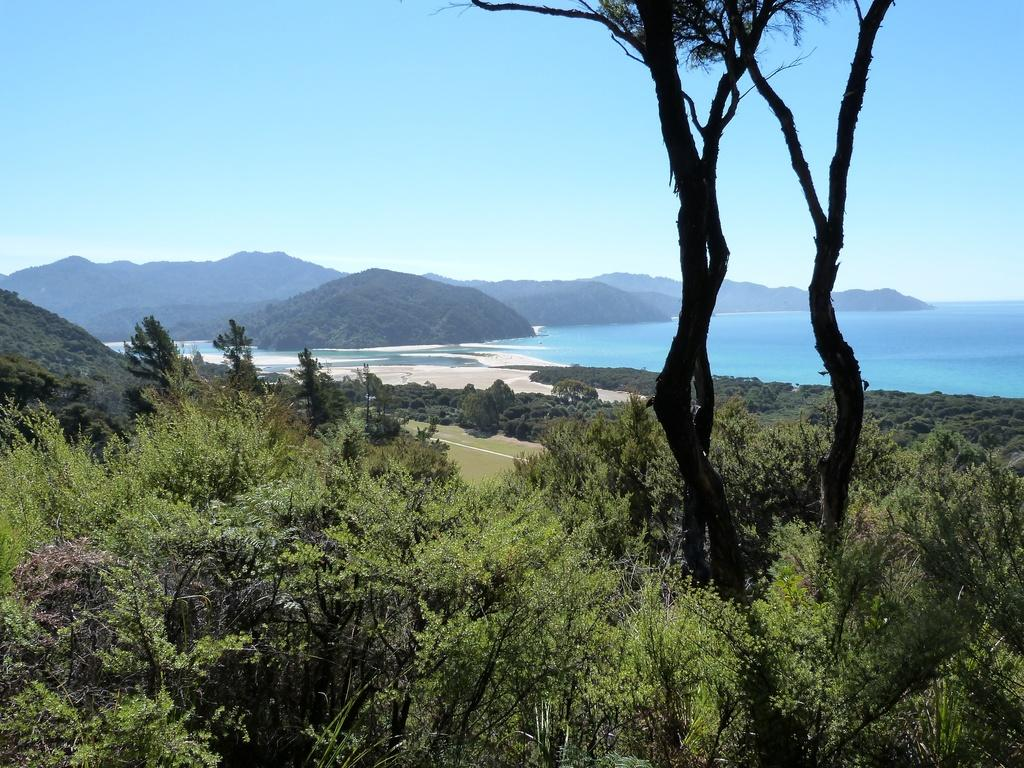What type of natural environment is depicted in the image? The image features trees, water, and hills, which suggests a natural landscape. Can you describe the water in the image? There is water visible in the image, but its specific characteristics are not mentioned in the facts. What is the condition of the sky in the image? The sky is blue and cloudy in the image. What type of vest is the creator wearing in the image? There is no creator or vest present in the image; it features a natural landscape with trees, water, hills, and a blue, cloudy sky. 